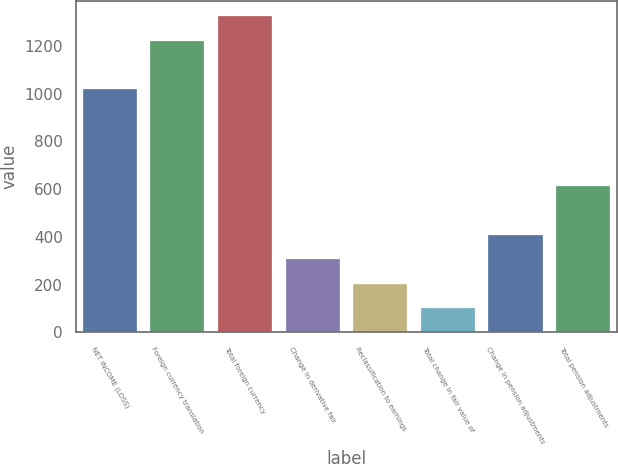Convert chart to OTSL. <chart><loc_0><loc_0><loc_500><loc_500><bar_chart><fcel>NET INCOME (LOSS)<fcel>Foreign currency translation<fcel>Total foreign currency<fcel>Change in derivative fair<fcel>Reclassification to earnings<fcel>Total change in fair value of<fcel>Change in pension adjustments<fcel>Total pension adjustments<nl><fcel>1019<fcel>1222.6<fcel>1324.4<fcel>306.4<fcel>204.6<fcel>102.8<fcel>408.2<fcel>611.8<nl></chart> 